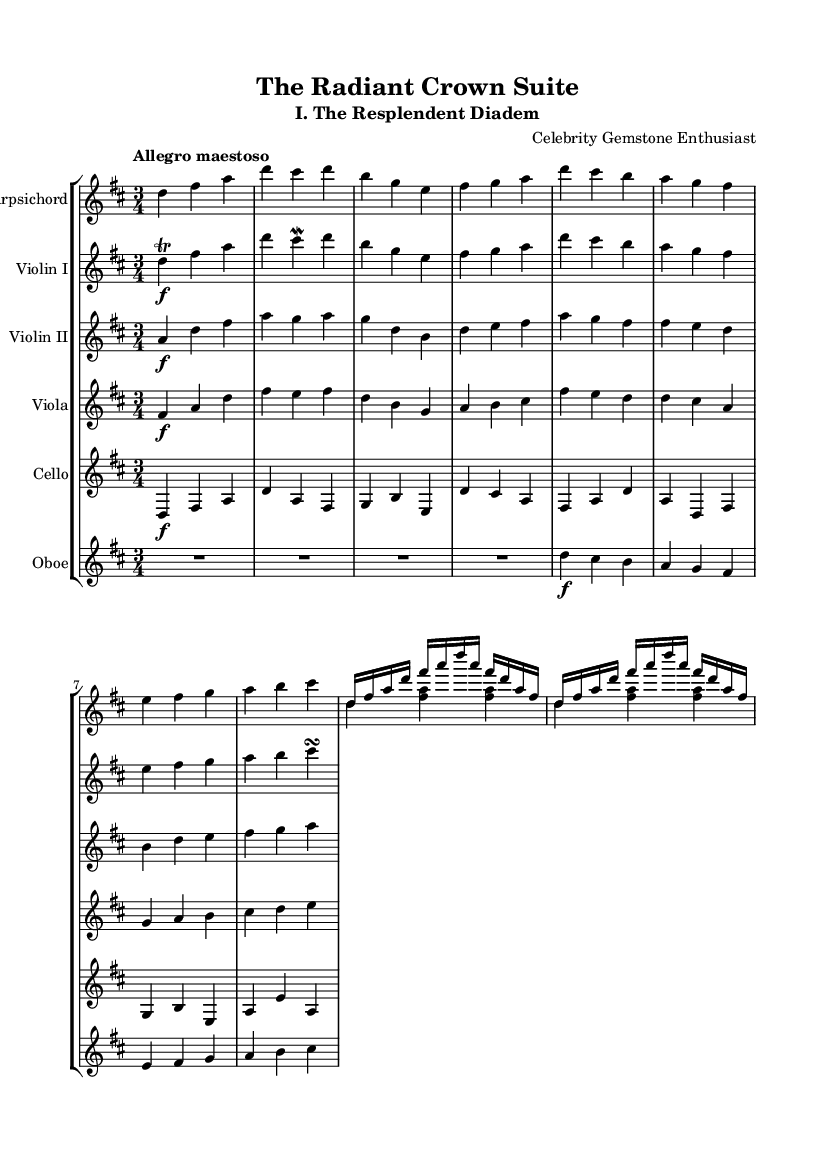What is the time signature of this music? The time signature is indicated right after the key signature and shows the number of beats in each measure. Here, it is marked as 3 over 4, meaning there are three beats per measure and each quarter note gets one beat.
Answer: 3/4 What is the tempo marking for this piece? The tempo marking is found at the beginning of the piece and indicates the desired speed of performance. Here, "Allegro maestoso" suggests a lively and majestic tempo.
Answer: Allegro maestoso How many instruments are featured in this score? By counting the different staves present in the score, we can identify the instruments. There are six distinct staves: Harpsichord, Violin I, Violin II, Viola, Cello, and Oboe.
Answer: Six What key is this suite composed in? The key signature is indicated at the beginning of the score. Here, it shows F# and C# as sharps, which identifies it as D major.
Answer: D major What is the dynamic marking for Violin I at the beginning? The dynamic marking for Violin I is found in the first measure at the beginning of the stave, marked as forte (f), indicating it should be played loudly.
Answer: Forte Which ornament is used in the first measure of Violin I? The score contains an ornamentation symbol above the note in the first measure, specifically a trill, which instructs the performer to rapidly alternate between the written note and its upper neighbor.
Answer: Trill What style is this suite written in? This piece belongs to the Baroque period, known for its ornate musical texture and elaborate ornamentation distinct to the era, as seen in both the scoring and stylistic choices.
Answer: Baroque 